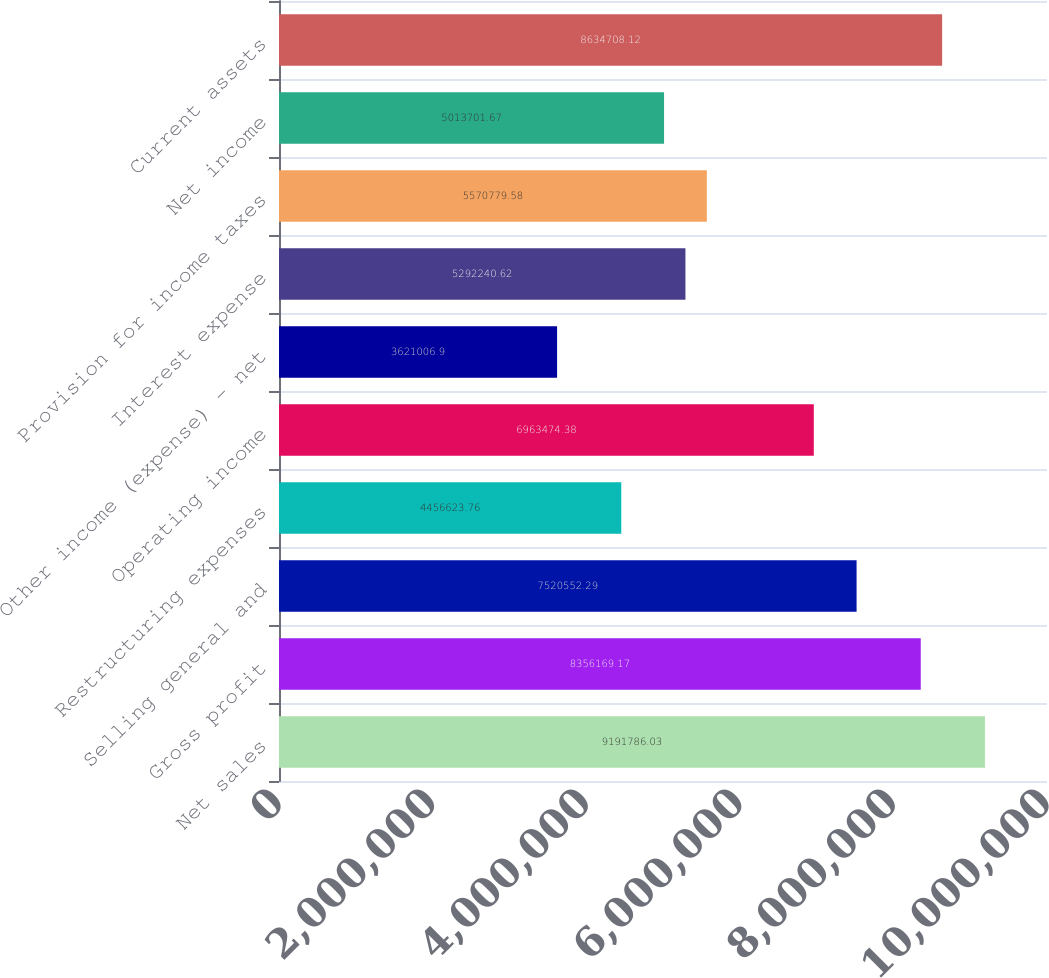<chart> <loc_0><loc_0><loc_500><loc_500><bar_chart><fcel>Net sales<fcel>Gross profit<fcel>Selling general and<fcel>Restructuring expenses<fcel>Operating income<fcel>Other income (expense) - net<fcel>Interest expense<fcel>Provision for income taxes<fcel>Net income<fcel>Current assets<nl><fcel>9.19179e+06<fcel>8.35617e+06<fcel>7.52055e+06<fcel>4.45662e+06<fcel>6.96347e+06<fcel>3.62101e+06<fcel>5.29224e+06<fcel>5.57078e+06<fcel>5.0137e+06<fcel>8.63471e+06<nl></chart> 